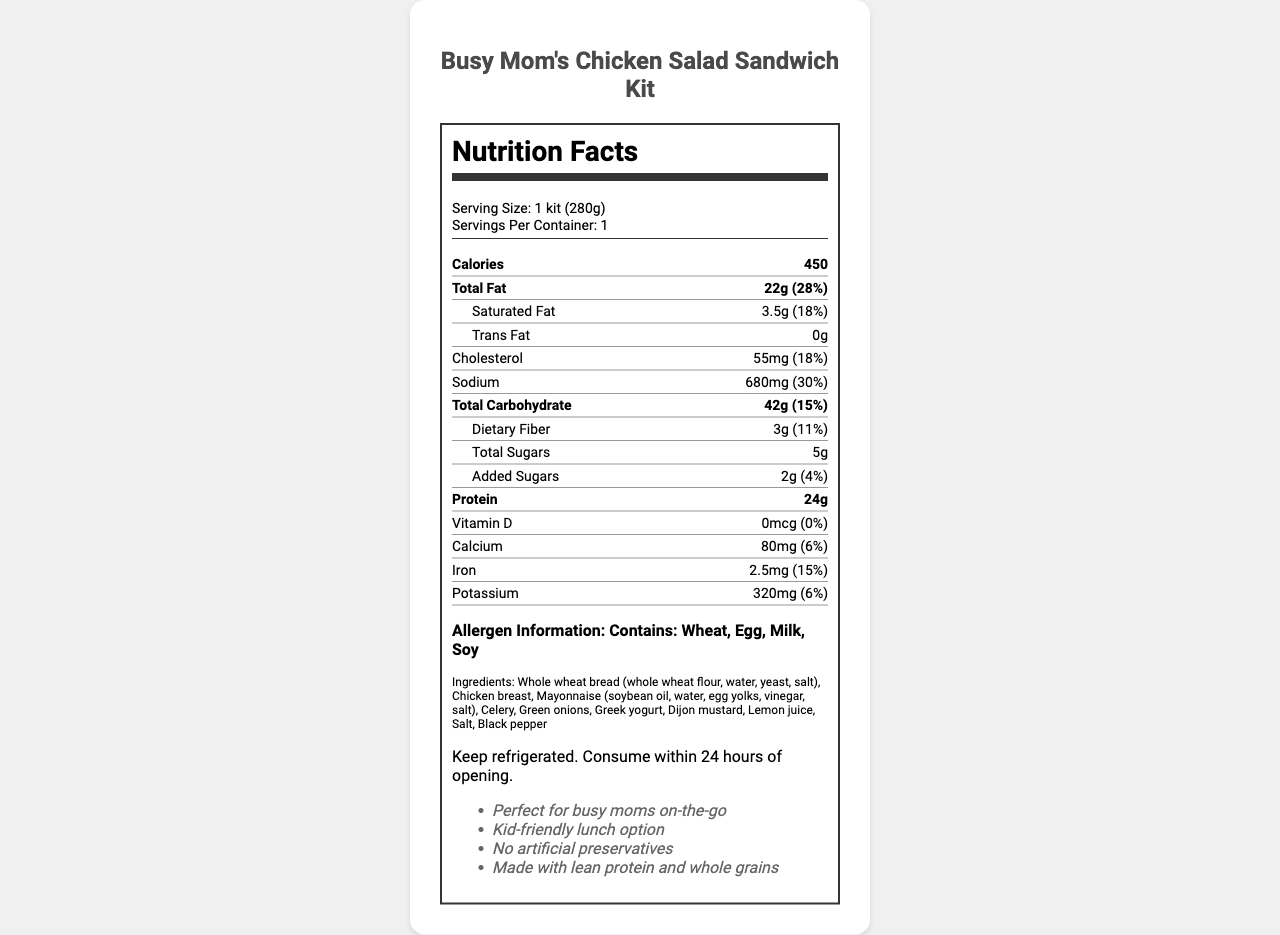what is the serving size? The serving size is specified at the top of the Nutrition Facts label.
Answer: 1 kit (280g) how many servings per container? The document clearly lists that there is 1 serving per container.
Answer: 1 how many calories are in each serving? The Nutrition Facts label specifies that each serving contains 450 calories.
Answer: 450 how much total fat is in a serving? The label indicates that there is 22g of total fat per serving.
Answer: 22g what percentage of the daily value does the saturated fat make up? The label states that the daily value percentage for saturated fat is 18%.
Answer: 18% does this product contain any trans fat? The label indicates that the amount of trans fat is 0g.
Answer: No how much cholesterol is in one kit? The document specifies that there is 55mg of cholesterol per serving.
Answer: 55mg what is the sodium content in this product? The sodium content is listed as 680mg per serving.
Answer: 680mg how much dietary fiber does one serving have? The document lists dietary fiber as 3g per serving.
Answer: 3g how many grams of added sugars are included? The Nutrition Facts label indicates that there are 2g of added sugars in a serving.
Answer: 2g what allergens does this product contain? The allergens mentioned are Wheat, Egg, Milk, and Soy.
Answer: Wheat, Egg, Milk, Soy what is the main ingredient in the whole wheat bread? A. Yeast B. Whole wheat flour C. Salt D. Water Whole wheat bread's main ingredient is listed as whole wheat flour.
Answer: B how is the product stored after opening? A. Freeze immediately B. Keep frozen C. Keep refrigerated D. Store at room temperature The preparation instructions indicate to keep the product refrigerated after opening.
Answer: C is the product made with lean protein? The additional information explicitly states that the product is made with lean protein.
Answer: Yes summarize the main idea of the document. The document provides a Nutrition Facts label for the product, containing serving size, calorie count, macronutrient breakdown, vitamins and minerals, allergens, ingredients, preparation instructions, and additional benefits.
Answer: Busy Mom's Chicken Salad Sandwich Kit is a convenient, pre-packaged lunch item with detailed nutritional information, allergen declarations, and ingredient lists, ideal for busy moms and children. what is the sugar content in this product? The total sugars in the product are indicated as 5g per serving.
Answer: 5g what percentage of the daily value of iron does this product provide? The label states that this product provides 15% of the daily value for iron.
Answer: 15% is this product free of artificial preservatives? The additional information specifies that the product contains no artificial preservatives.
Answer: Yes how much calcium does one serving have? The nutrient information lists the calcium content as 80mg per serving.
Answer: 80mg who is the target audience for this product? The additional information lists "Perfect for busy moms on-the-go" and "Kid-friendly lunch option" indicating the target audience.
Answer: Busy moms and children how much protein is in the entire container? The protein content per serving is specified as 24g.
Answer: 24g does the document mention the cost of the product? The document does not provide any information regarding the cost of the product.
Answer: Not enough information 